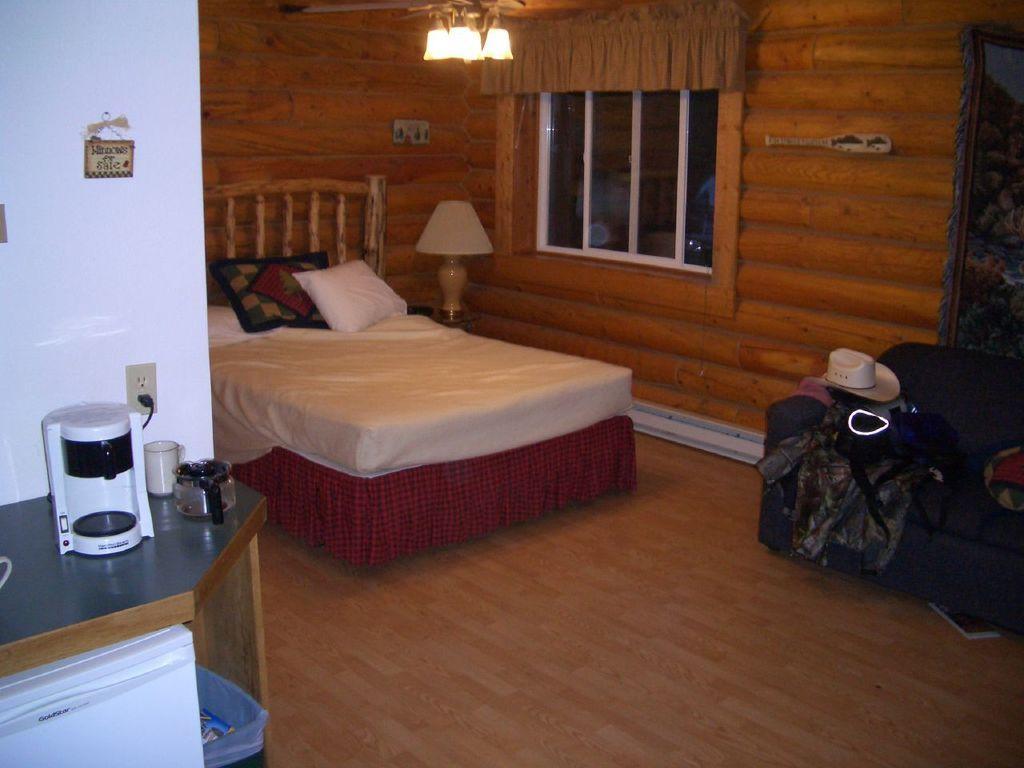Could you give a brief overview of what you see in this image? In this image, we can see an inside view of a room. There is a bed in the middle of the image beside the window. There is a light at the top of the image. There is a hat on the sofa which is on the right side of the image. There is a counter top in the bottom left of the image contains a glass, jar and flask. There is a banner in the top right of the image. 